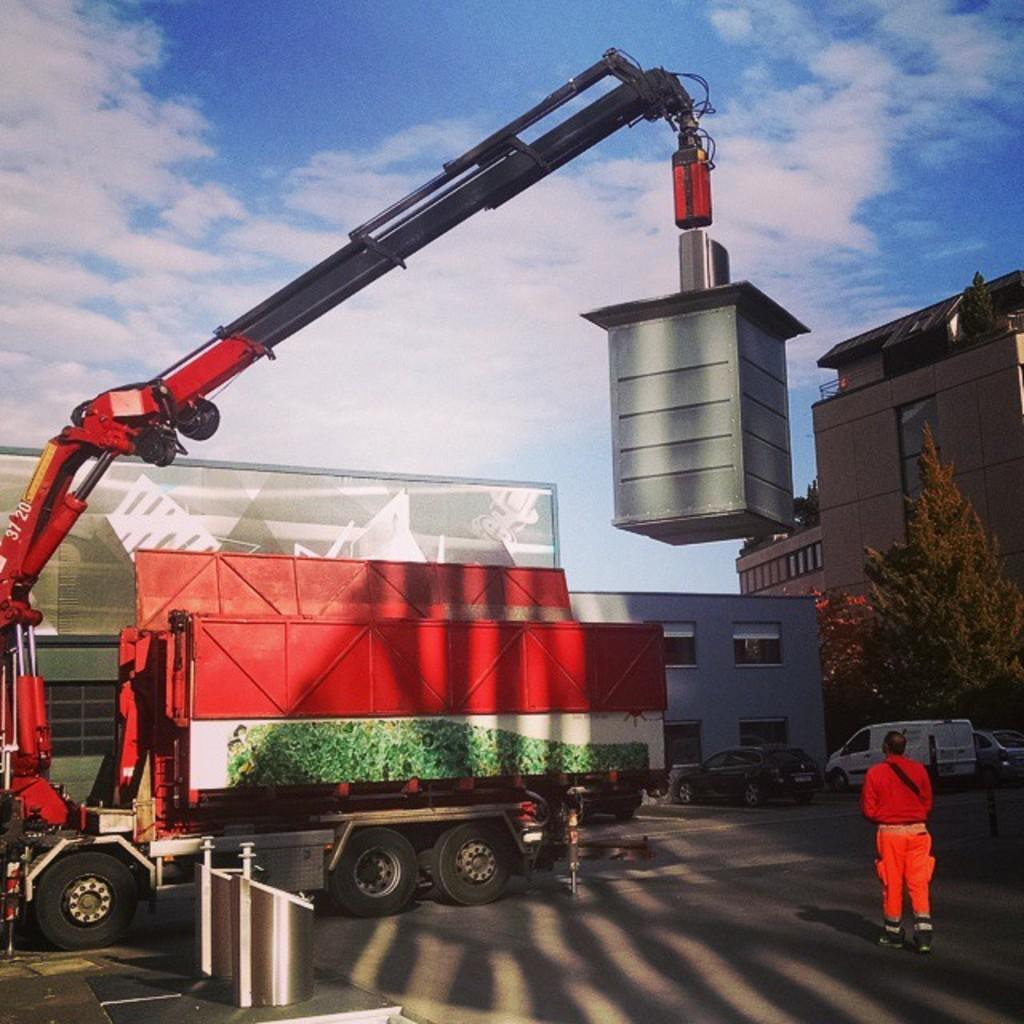<image>
Present a compact description of the photo's key features. Man standing under a crane with the numbers 3720 on it. 